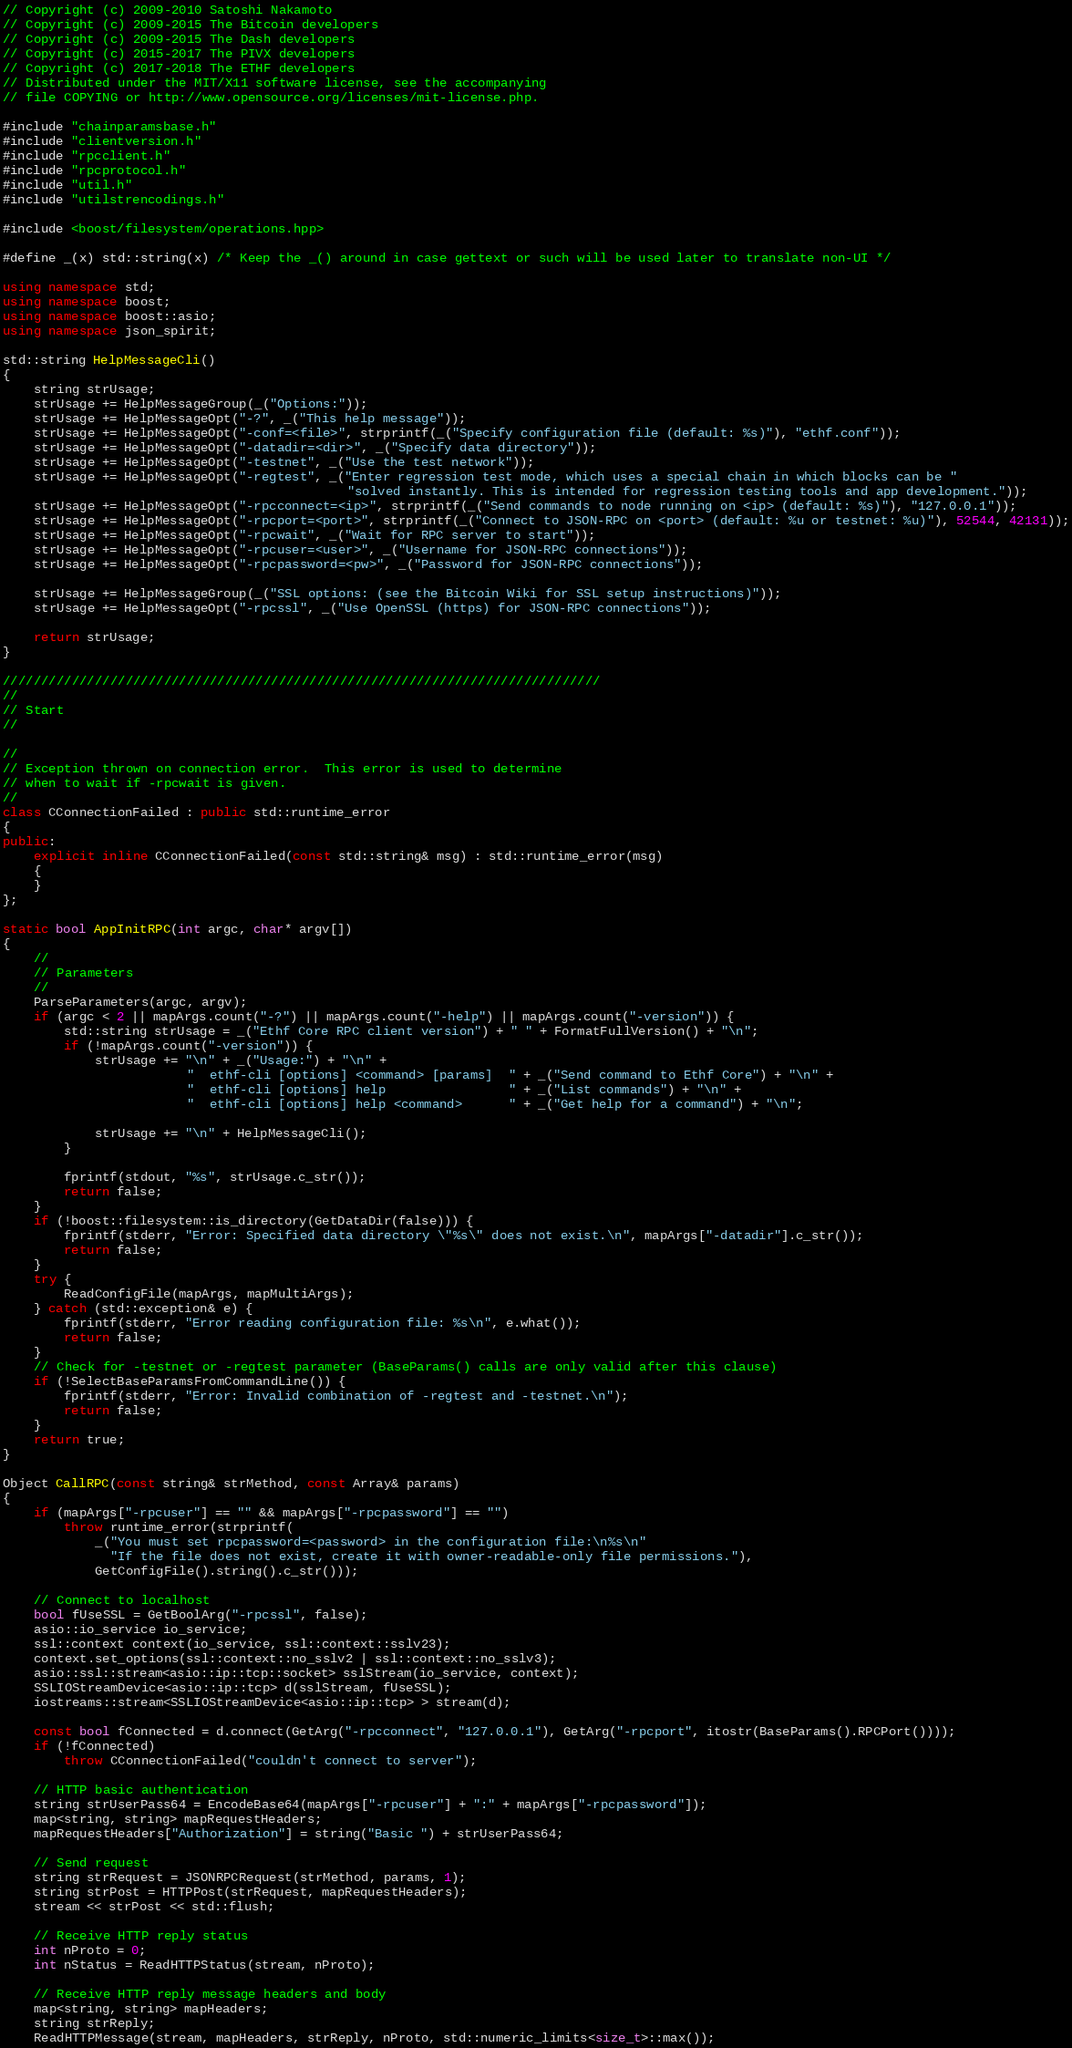Convert code to text. <code><loc_0><loc_0><loc_500><loc_500><_C++_>// Copyright (c) 2009-2010 Satoshi Nakamoto
// Copyright (c) 2009-2015 The Bitcoin developers
// Copyright (c) 2009-2015 The Dash developers
// Copyright (c) 2015-2017 The PIVX developers
// Copyright (c) 2017-2018 The ETHF developers
// Distributed under the MIT/X11 software license, see the accompanying
// file COPYING or http://www.opensource.org/licenses/mit-license.php.

#include "chainparamsbase.h"
#include "clientversion.h"
#include "rpcclient.h"
#include "rpcprotocol.h"
#include "util.h"
#include "utilstrencodings.h"

#include <boost/filesystem/operations.hpp>

#define _(x) std::string(x) /* Keep the _() around in case gettext or such will be used later to translate non-UI */

using namespace std;
using namespace boost;
using namespace boost::asio;
using namespace json_spirit;

std::string HelpMessageCli()
{
    string strUsage;
    strUsage += HelpMessageGroup(_("Options:"));
    strUsage += HelpMessageOpt("-?", _("This help message"));
    strUsage += HelpMessageOpt("-conf=<file>", strprintf(_("Specify configuration file (default: %s)"), "ethf.conf"));
    strUsage += HelpMessageOpt("-datadir=<dir>", _("Specify data directory"));
    strUsage += HelpMessageOpt("-testnet", _("Use the test network"));
    strUsage += HelpMessageOpt("-regtest", _("Enter regression test mode, which uses a special chain in which blocks can be "
                                             "solved instantly. This is intended for regression testing tools and app development."));
    strUsage += HelpMessageOpt("-rpcconnect=<ip>", strprintf(_("Send commands to node running on <ip> (default: %s)"), "127.0.0.1"));
    strUsage += HelpMessageOpt("-rpcport=<port>", strprintf(_("Connect to JSON-RPC on <port> (default: %u or testnet: %u)"), 52544, 42131));
    strUsage += HelpMessageOpt("-rpcwait", _("Wait for RPC server to start"));
    strUsage += HelpMessageOpt("-rpcuser=<user>", _("Username for JSON-RPC connections"));
    strUsage += HelpMessageOpt("-rpcpassword=<pw>", _("Password for JSON-RPC connections"));

    strUsage += HelpMessageGroup(_("SSL options: (see the Bitcoin Wiki for SSL setup instructions)"));
    strUsage += HelpMessageOpt("-rpcssl", _("Use OpenSSL (https) for JSON-RPC connections"));

    return strUsage;
}

//////////////////////////////////////////////////////////////////////////////
//
// Start
//

//
// Exception thrown on connection error.  This error is used to determine
// when to wait if -rpcwait is given.
//
class CConnectionFailed : public std::runtime_error
{
public:
    explicit inline CConnectionFailed(const std::string& msg) : std::runtime_error(msg)
    {
    }
};

static bool AppInitRPC(int argc, char* argv[])
{
    //
    // Parameters
    //
    ParseParameters(argc, argv);
    if (argc < 2 || mapArgs.count("-?") || mapArgs.count("-help") || mapArgs.count("-version")) {
        std::string strUsage = _("Ethf Core RPC client version") + " " + FormatFullVersion() + "\n";
        if (!mapArgs.count("-version")) {
            strUsage += "\n" + _("Usage:") + "\n" +
                        "  ethf-cli [options] <command> [params]  " + _("Send command to Ethf Core") + "\n" +
                        "  ethf-cli [options] help                " + _("List commands") + "\n" +
                        "  ethf-cli [options] help <command>      " + _("Get help for a command") + "\n";

            strUsage += "\n" + HelpMessageCli();
        }

        fprintf(stdout, "%s", strUsage.c_str());
        return false;
    }
    if (!boost::filesystem::is_directory(GetDataDir(false))) {
        fprintf(stderr, "Error: Specified data directory \"%s\" does not exist.\n", mapArgs["-datadir"].c_str());
        return false;
    }
    try {
        ReadConfigFile(mapArgs, mapMultiArgs);
    } catch (std::exception& e) {
        fprintf(stderr, "Error reading configuration file: %s\n", e.what());
        return false;
    }
    // Check for -testnet or -regtest parameter (BaseParams() calls are only valid after this clause)
    if (!SelectBaseParamsFromCommandLine()) {
        fprintf(stderr, "Error: Invalid combination of -regtest and -testnet.\n");
        return false;
    }
    return true;
}

Object CallRPC(const string& strMethod, const Array& params)
{
    if (mapArgs["-rpcuser"] == "" && mapArgs["-rpcpassword"] == "")
        throw runtime_error(strprintf(
            _("You must set rpcpassword=<password> in the configuration file:\n%s\n"
              "If the file does not exist, create it with owner-readable-only file permissions."),
            GetConfigFile().string().c_str()));

    // Connect to localhost
    bool fUseSSL = GetBoolArg("-rpcssl", false);
    asio::io_service io_service;
    ssl::context context(io_service, ssl::context::sslv23);
    context.set_options(ssl::context::no_sslv2 | ssl::context::no_sslv3);
    asio::ssl::stream<asio::ip::tcp::socket> sslStream(io_service, context);
    SSLIOStreamDevice<asio::ip::tcp> d(sslStream, fUseSSL);
    iostreams::stream<SSLIOStreamDevice<asio::ip::tcp> > stream(d);

    const bool fConnected = d.connect(GetArg("-rpcconnect", "127.0.0.1"), GetArg("-rpcport", itostr(BaseParams().RPCPort())));
    if (!fConnected)
        throw CConnectionFailed("couldn't connect to server");

    // HTTP basic authentication
    string strUserPass64 = EncodeBase64(mapArgs["-rpcuser"] + ":" + mapArgs["-rpcpassword"]);
    map<string, string> mapRequestHeaders;
    mapRequestHeaders["Authorization"] = string("Basic ") + strUserPass64;

    // Send request
    string strRequest = JSONRPCRequest(strMethod, params, 1);
    string strPost = HTTPPost(strRequest, mapRequestHeaders);
    stream << strPost << std::flush;

    // Receive HTTP reply status
    int nProto = 0;
    int nStatus = ReadHTTPStatus(stream, nProto);

    // Receive HTTP reply message headers and body
    map<string, string> mapHeaders;
    string strReply;
    ReadHTTPMessage(stream, mapHeaders, strReply, nProto, std::numeric_limits<size_t>::max());
</code> 